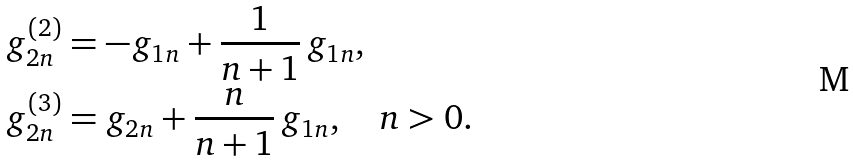Convert formula to latex. <formula><loc_0><loc_0><loc_500><loc_500>g ^ { ( 2 ) } _ { 2 n } & = - g _ { 1 n } + \frac { 1 } { n + 1 } \, g _ { 1 n } , \\ g ^ { ( 3 ) } _ { 2 n } & = g _ { 2 n } + \frac { n } { n + 1 } \, g _ { 1 n } , \quad n > 0 .</formula> 